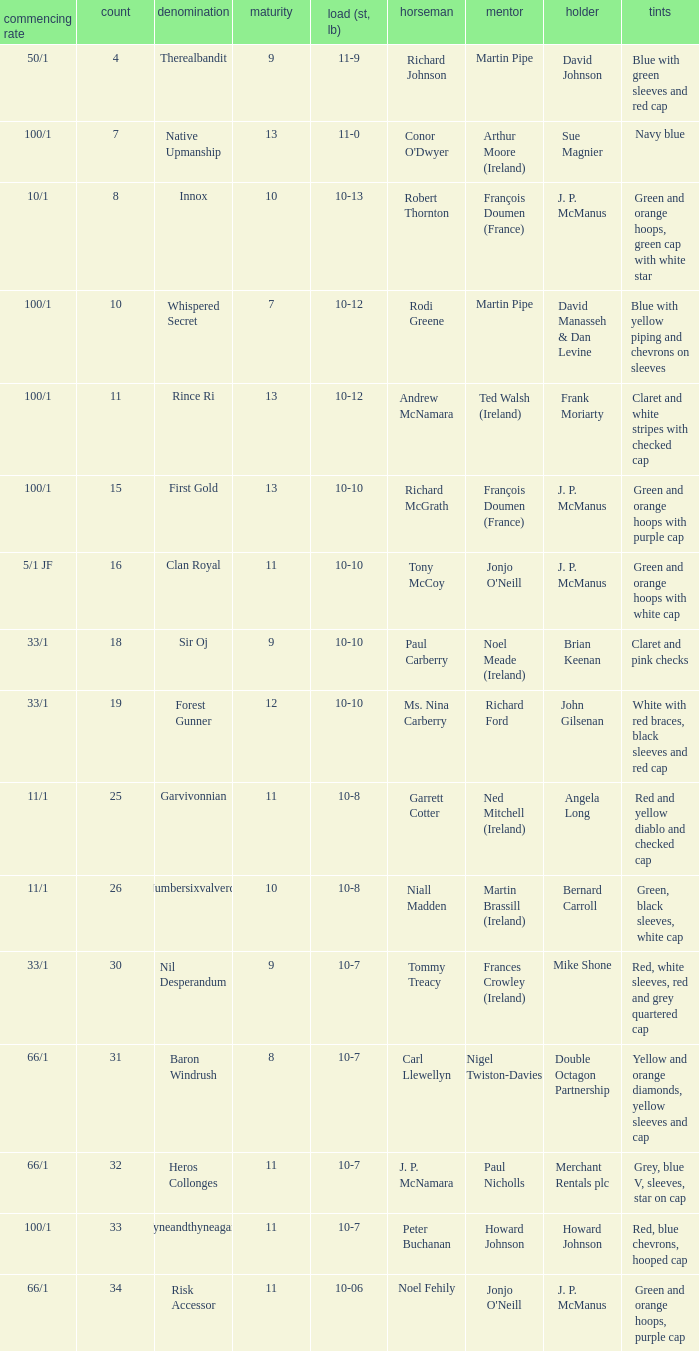What was the name of the entrant with an owner named David Johnson? Therealbandit. 